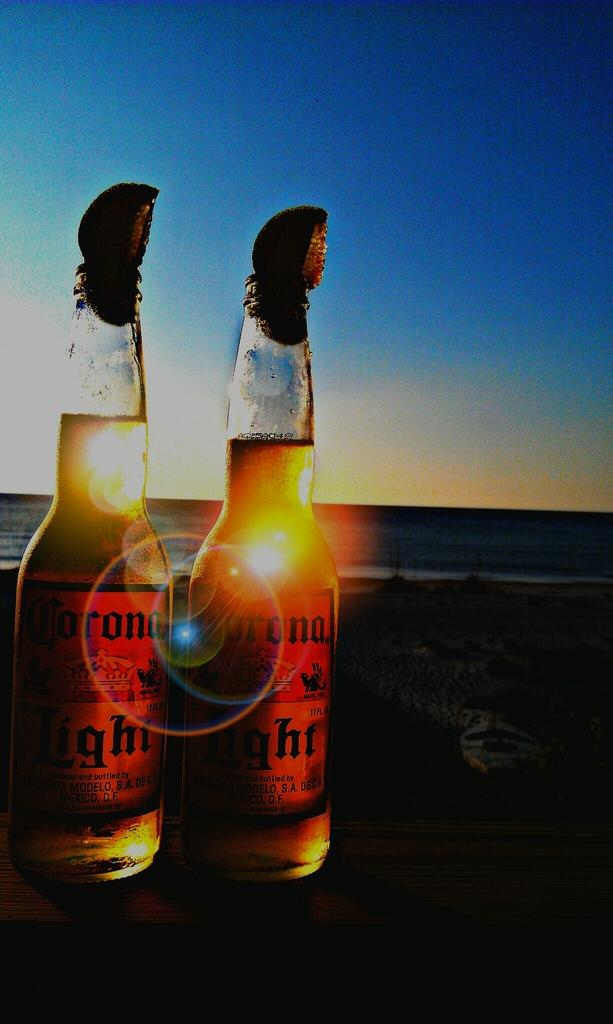<image>
Give a short and clear explanation of the subsequent image. Two bottles of Corona Light next to a beach. 